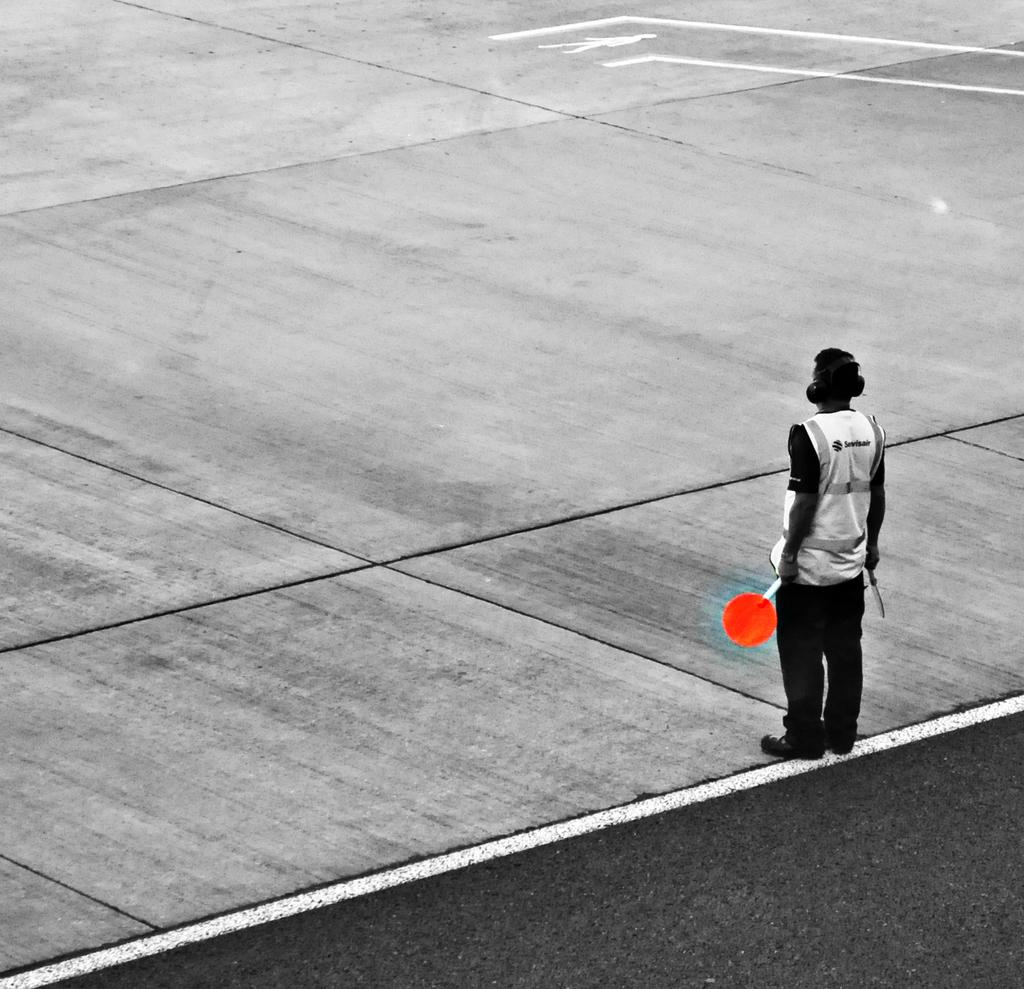Who is the main subject in the foreground of the image? A: There is a man in the foreground of the image. What is the man holding in his hands? The man is holding two boards in his hands. What can be seen in the background of the image? There is a road visible at the top of the image. Can you see any ducks swimming in the water near the dock in the image? There is no dock or water visible in the image, and therefore no ducks can be seen swimming. 